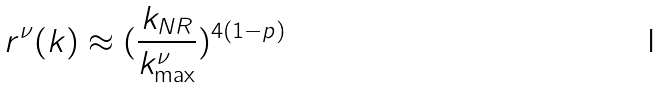Convert formula to latex. <formula><loc_0><loc_0><loc_500><loc_500>r ^ { \nu } ( k ) \approx ( \frac { k _ { N R } } { k _ { \max } ^ { \nu } } ) ^ { 4 ( 1 - p ) }</formula> 